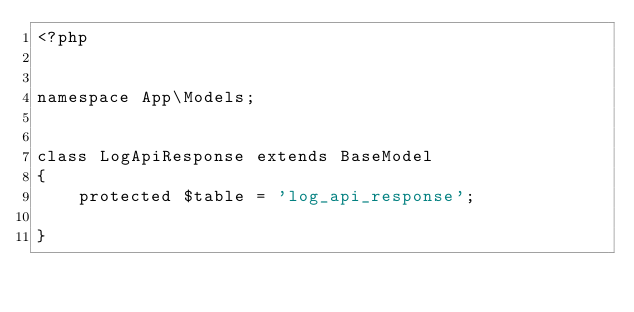Convert code to text. <code><loc_0><loc_0><loc_500><loc_500><_PHP_><?php


namespace App\Models;


class LogApiResponse extends BaseModel
{
    protected $table = 'log_api_response';

}
</code> 